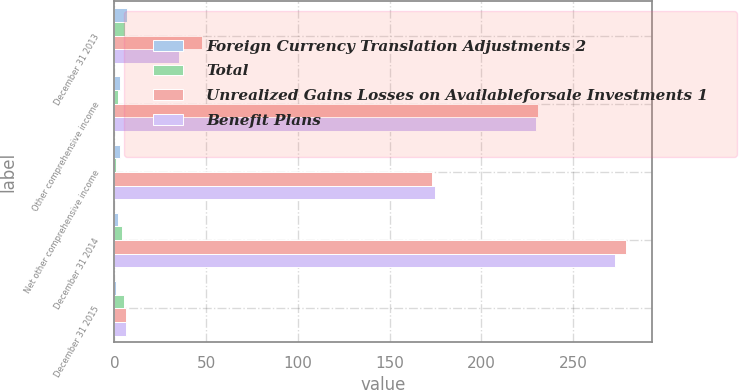<chart> <loc_0><loc_0><loc_500><loc_500><stacked_bar_chart><ecel><fcel>December 31 2013<fcel>Other comprehensive income<fcel>Net other comprehensive income<fcel>December 31 2014<fcel>December 31 2015<nl><fcel>Foreign Currency Translation Adjustments 2<fcel>7<fcel>3<fcel>3<fcel>2<fcel>1<nl><fcel>Total<fcel>6<fcel>2<fcel>1<fcel>4<fcel>5<nl><fcel>Unrealized Gains Losses on Availableforsale Investments 1<fcel>48<fcel>231<fcel>173<fcel>279<fcel>6.5<nl><fcel>Benefit Plans<fcel>35<fcel>230<fcel>175<fcel>273<fcel>6.5<nl></chart> 